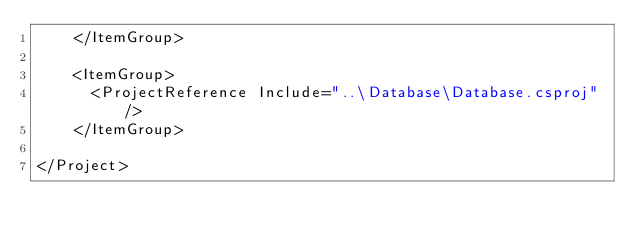Convert code to text. <code><loc_0><loc_0><loc_500><loc_500><_XML_>    </ItemGroup>

    <ItemGroup>
      <ProjectReference Include="..\Database\Database.csproj" />
    </ItemGroup>

</Project>
</code> 